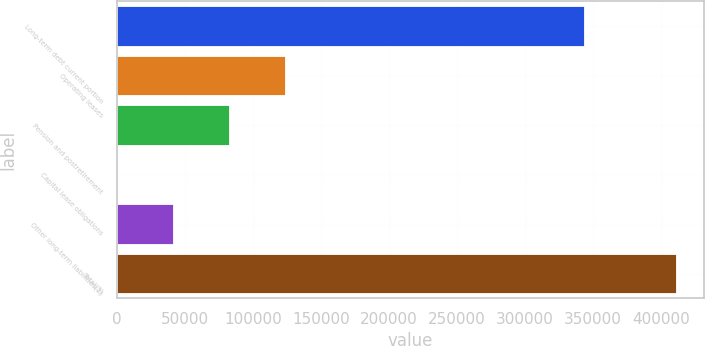Convert chart. <chart><loc_0><loc_0><loc_500><loc_500><bar_chart><fcel>Long-term debt current portion<fcel>Operating leases<fcel>Pension and postretirement<fcel>Capital lease obligations<fcel>Other long-term liabilities(2)<fcel>Total(3)<nl><fcel>343770<fcel>123491<fcel>82407.6<fcel>240<fcel>41323.8<fcel>411078<nl></chart> 